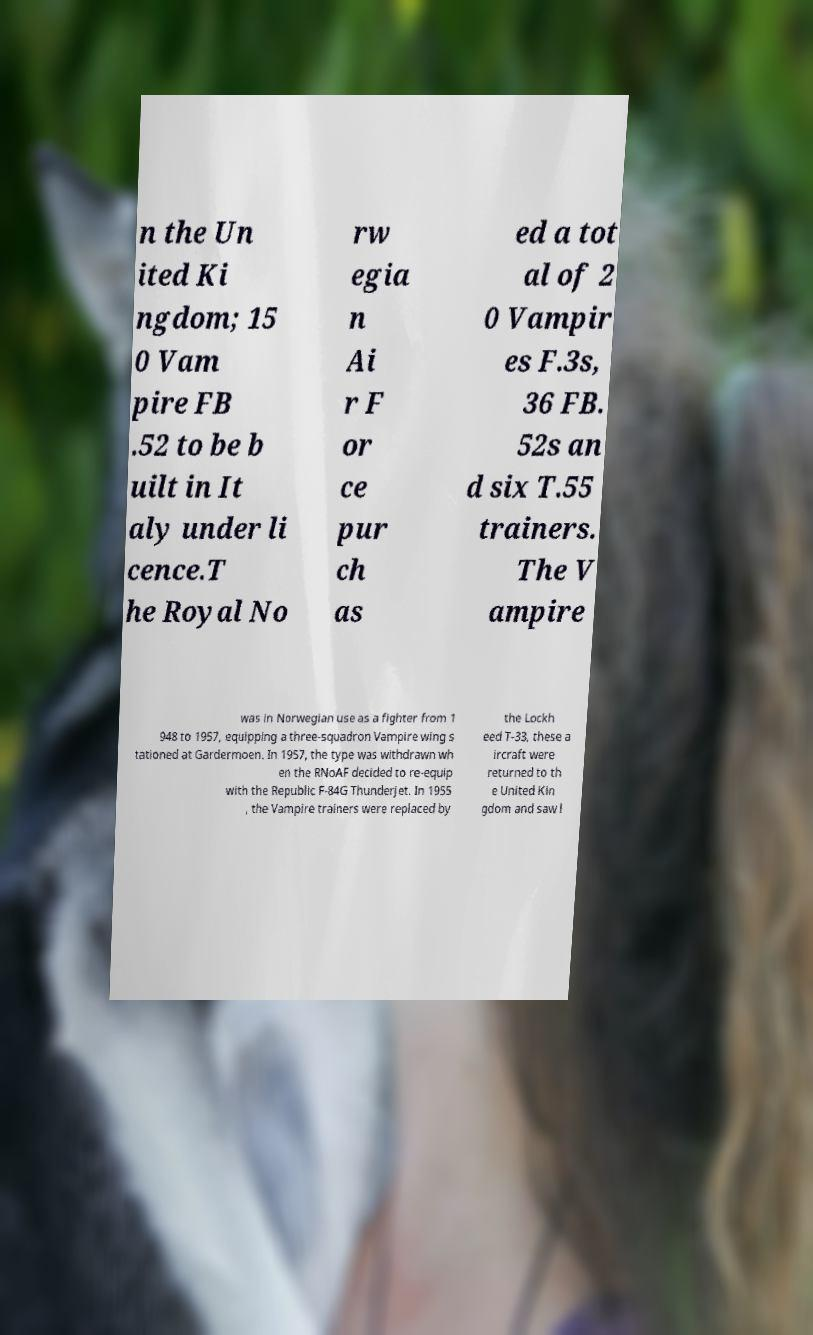What messages or text are displayed in this image? I need them in a readable, typed format. n the Un ited Ki ngdom; 15 0 Vam pire FB .52 to be b uilt in It aly under li cence.T he Royal No rw egia n Ai r F or ce pur ch as ed a tot al of 2 0 Vampir es F.3s, 36 FB. 52s an d six T.55 trainers. The V ampire was in Norwegian use as a fighter from 1 948 to 1957, equipping a three-squadron Vampire wing s tationed at Gardermoen. In 1957, the type was withdrawn wh en the RNoAF decided to re-equip with the Republic F-84G Thunderjet. In 1955 , the Vampire trainers were replaced by the Lockh eed T-33, these a ircraft were returned to th e United Kin gdom and saw l 